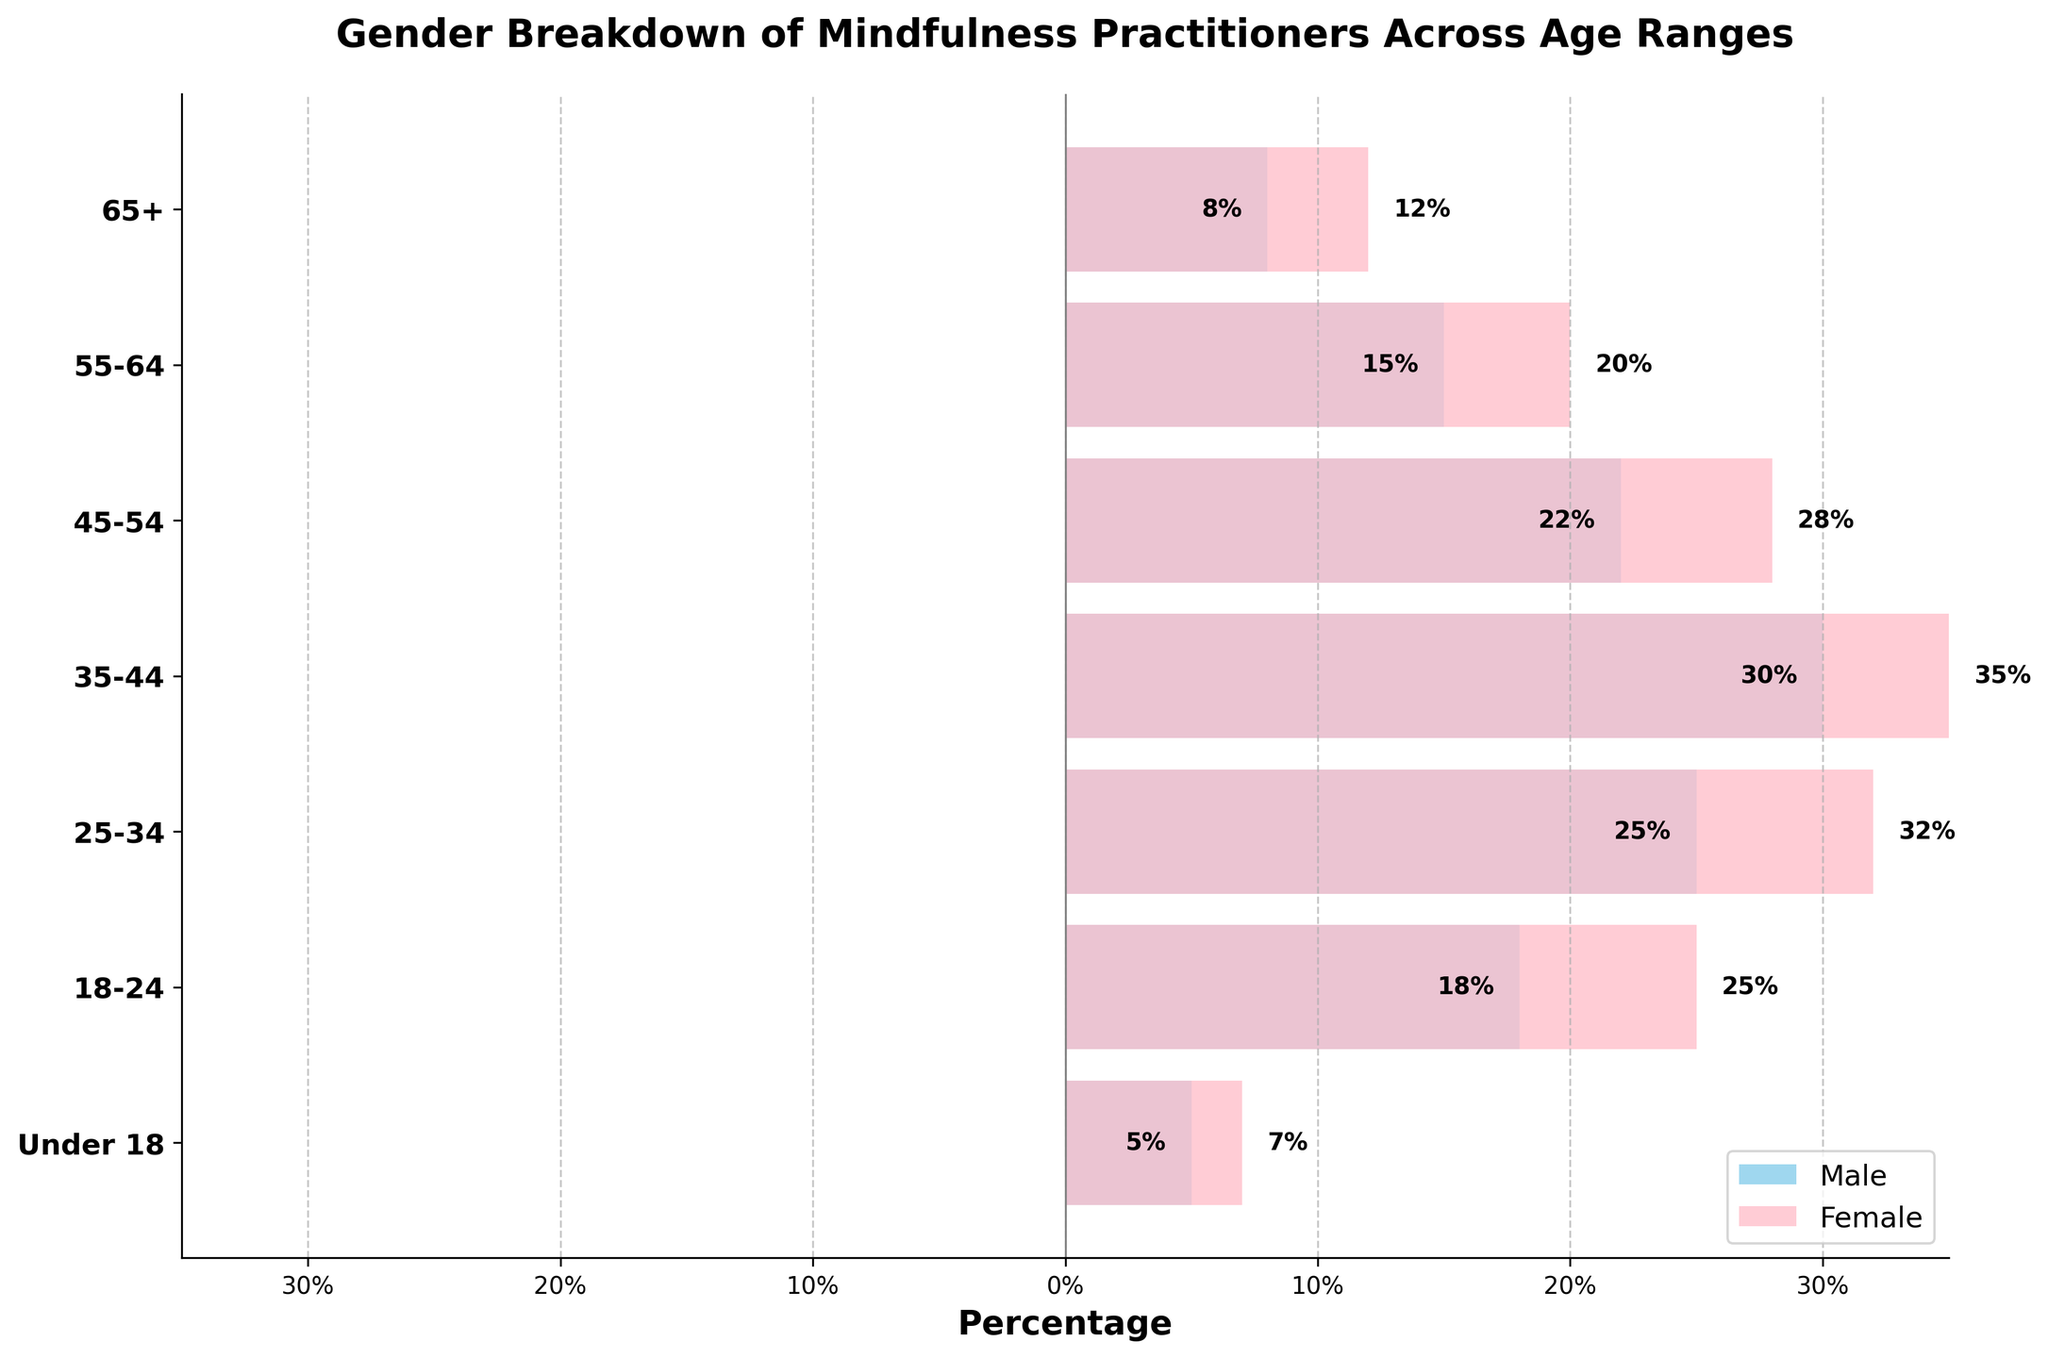what is the title of the figure? The title appears at the top of the figure and reads "Gender Breakdown of Mindfulness Practitioners Across Age Ranges".
Answer: Gender Breakdown of Mindfulness Practitioners Across Age Ranges What is the percentage of female mindfulness practitioners in the 35-44 age range? The bar on the pink (right) side for the 35-44 age range segment shows a value of 35%, representing female practitioners.
Answer: 35% Which gender has a higher percentage of mindfulness practitioners in the 18-24 age range, and by how much? The pink bar for females is at 25%, while the blue bar for males is at 18%. The difference is 25% - 18% = 7%.
Answer: Female, by 7% In which age range is the percentage difference between male and female mindfulness practitioners the greatest? Calculate the absolute differences for each age range and find the maximum: Under 18: 7%-5% = 2%, 18-24: 25%-18% = 7%, 25-34: 32%-25% = 7%, 35-44: 35%-30% = 5%, 45-54: 28%-22% = 6%, 55-64: 20%-15% = 5%, 65+: 12%-8% = 4%. The greatest difference is 7%, occurring in both the 18-24 and 25-34 age ranges.
Answer: 18-24 and 25-34 What percentage of male mindfulness practitioners are there in the 55-64 age range? The bar on the left side for males in the 55-64 age range shows -15%. Representing a percentage of 15%, ignoring the negative sign used for position.
Answer: 15% What percentage of female mindfulness practitioners are there in the Under 18 age range? The pink bar for females in the Under 18 age range shows a value of 7%.
Answer: 7% Out of the 35-44 and 45-54 age ranges, which has the higher combined total percentage of mindfulness practitioners across both genders? For 35-44: Male 30% + Female 35% = 65%. For 45-54: Male 22% + Female 28% = 50%. Thus, the 35-44 age range has a higher combined total percentage.
Answer: 35-44 Compare the male and female percentages for the 65+ age range. Which gender has a higher percentage and by how much? The blue bar for males is at 8%, and the pink bar for females is at 12%. The difference is 12% - 8% = 4%.
Answer: Female, by 4% Which age range shows an equal contribution from both genders? By visual inspection, no age range shows equal contribution as no paired bars reach the same percentage on both sides.
Answer: None 